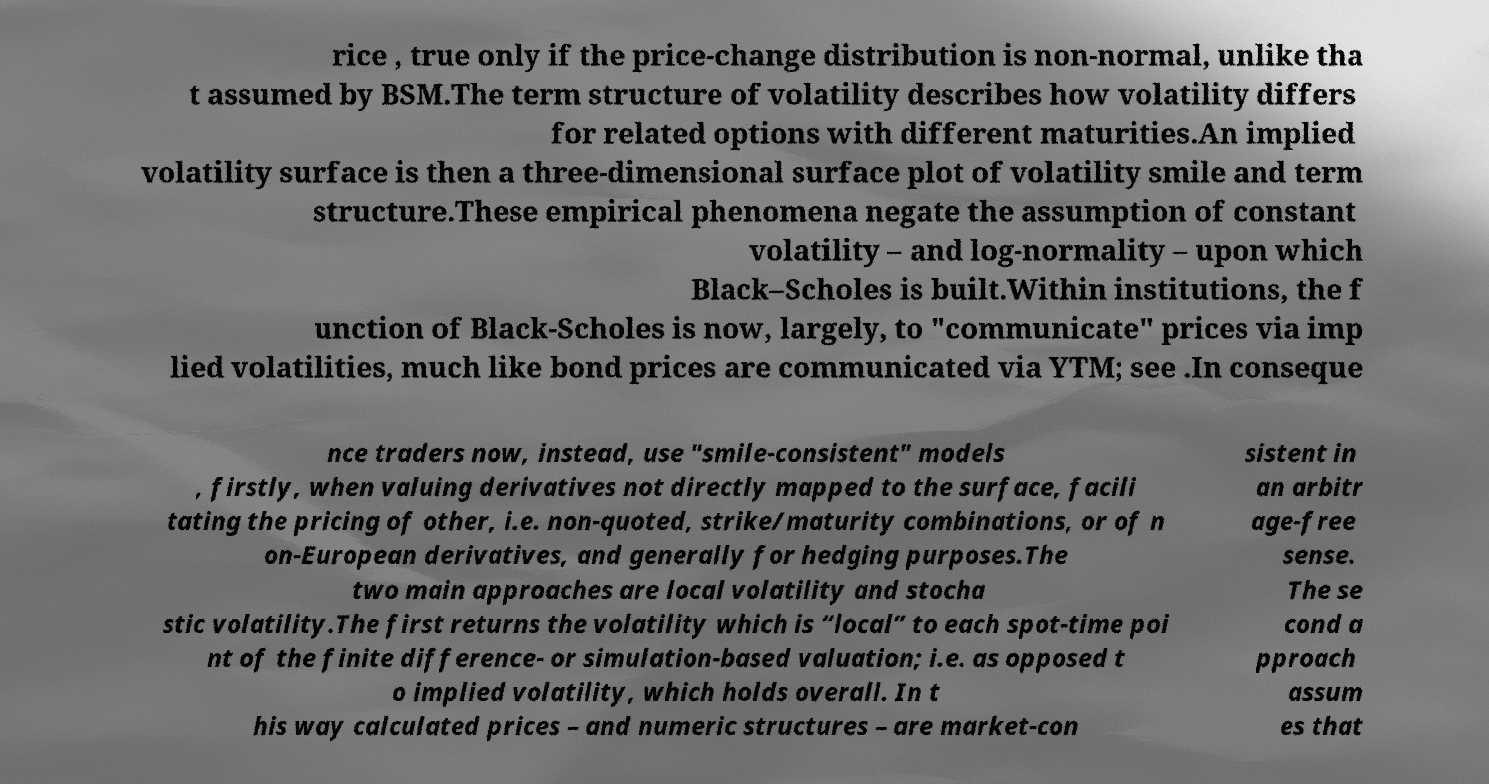For documentation purposes, I need the text within this image transcribed. Could you provide that? rice , true only if the price-change distribution is non-normal, unlike tha t assumed by BSM.The term structure of volatility describes how volatility differs for related options with different maturities.An implied volatility surface is then a three-dimensional surface plot of volatility smile and term structure.These empirical phenomena negate the assumption of constant volatility – and log-normality – upon which Black–Scholes is built.Within institutions, the f unction of Black-Scholes is now, largely, to "communicate" prices via imp lied volatilities, much like bond prices are communicated via YTM; see .In conseque nce traders now, instead, use "smile-consistent" models , firstly, when valuing derivatives not directly mapped to the surface, facili tating the pricing of other, i.e. non-quoted, strike/maturity combinations, or of n on-European derivatives, and generally for hedging purposes.The two main approaches are local volatility and stocha stic volatility.The first returns the volatility which is “local” to each spot-time poi nt of the finite difference- or simulation-based valuation; i.e. as opposed t o implied volatility, which holds overall. In t his way calculated prices – and numeric structures – are market-con sistent in an arbitr age-free sense. The se cond a pproach assum es that 